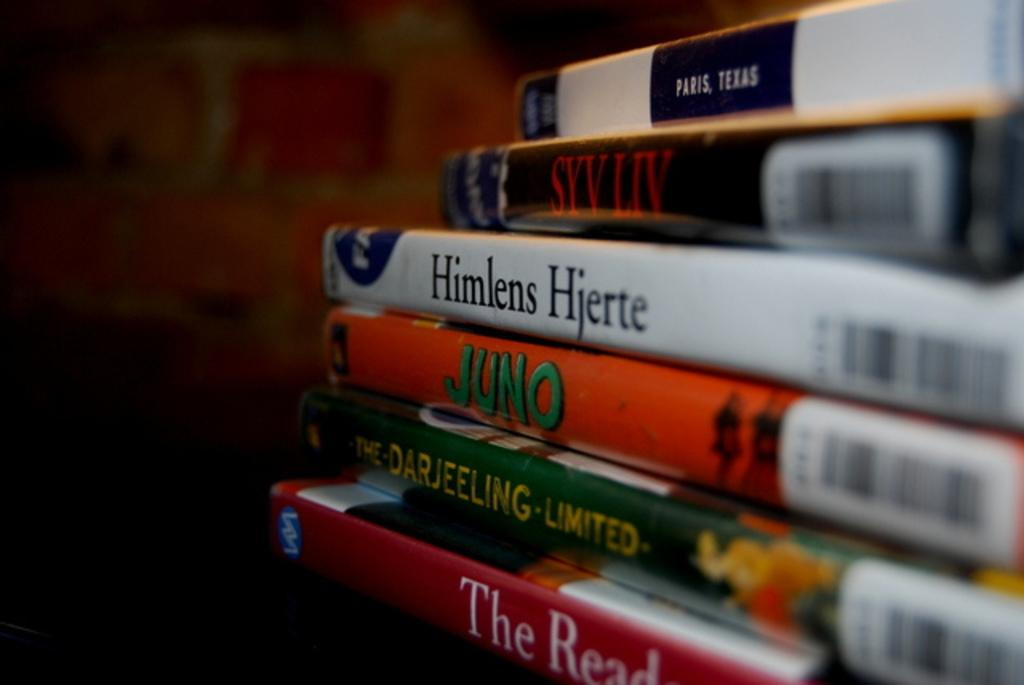Provide a one-sentence caption for the provided image. A stack of DVDs including The Darjeeling Limited. 